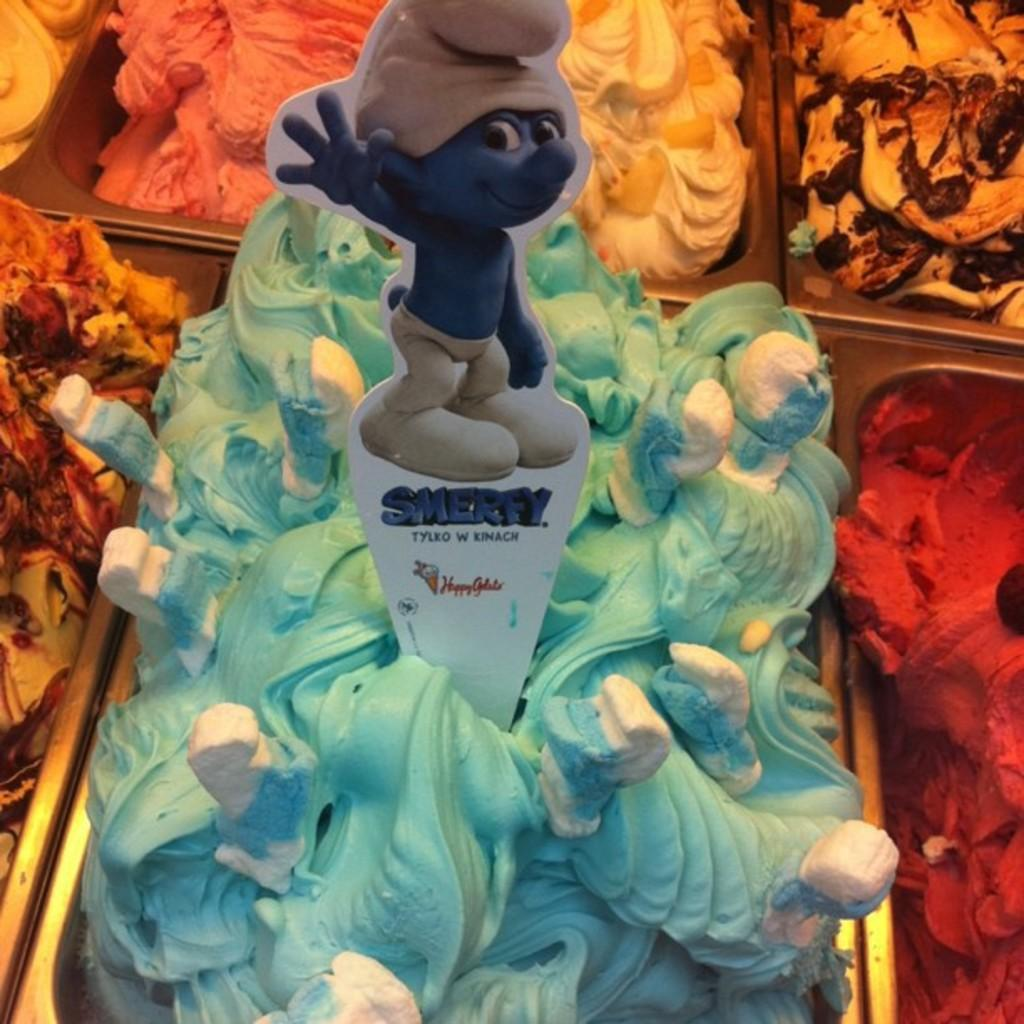What can be seen in the image in terms of ice cream? There are different flavors of ice cream in the image. How are the ice cream flavors arranged or contained? The ice cream is in a basket. Is there any utensil present in the image? Yes, there is a spoon in the middle of the ice cream. What type of writing can be seen on the walls of the hospital in the image? There is no hospital or writing present in the image; it features different flavors of ice cream in a basket with a spoon in the middle. 